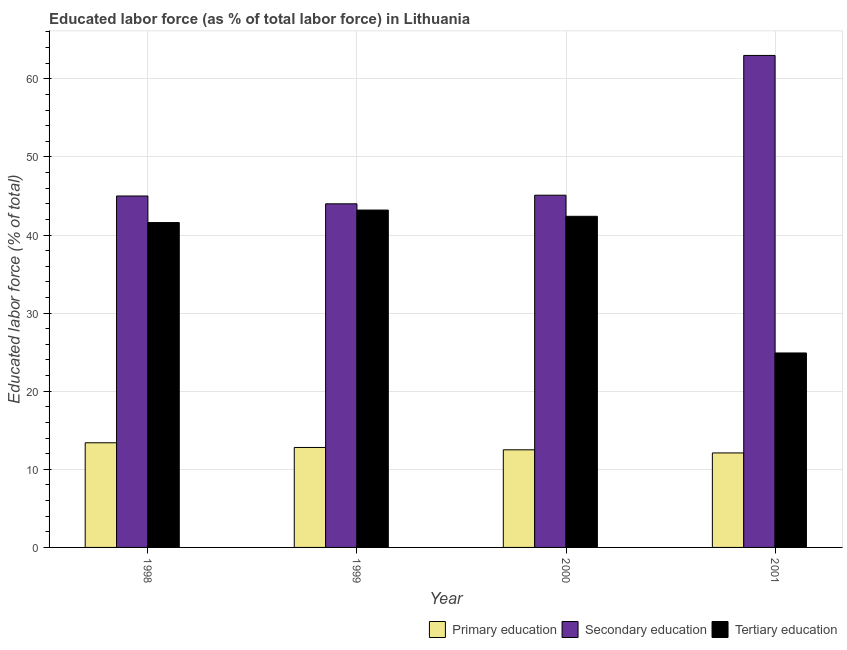How many groups of bars are there?
Provide a short and direct response. 4. Are the number of bars per tick equal to the number of legend labels?
Offer a very short reply. Yes. How many bars are there on the 4th tick from the left?
Give a very brief answer. 3. How many bars are there on the 4th tick from the right?
Offer a terse response. 3. What is the label of the 2nd group of bars from the left?
Ensure brevity in your answer.  1999. In how many cases, is the number of bars for a given year not equal to the number of legend labels?
Ensure brevity in your answer.  0. What is the percentage of labor force who received tertiary education in 2000?
Your response must be concise. 42.4. Across all years, what is the minimum percentage of labor force who received primary education?
Give a very brief answer. 12.1. In which year was the percentage of labor force who received secondary education maximum?
Provide a short and direct response. 2001. In which year was the percentage of labor force who received primary education minimum?
Provide a succinct answer. 2001. What is the total percentage of labor force who received tertiary education in the graph?
Offer a terse response. 152.1. What is the difference between the percentage of labor force who received tertiary education in 1998 and that in 2001?
Your answer should be very brief. 16.7. What is the difference between the percentage of labor force who received tertiary education in 2000 and the percentage of labor force who received primary education in 1998?
Your answer should be compact. 0.8. What is the average percentage of labor force who received tertiary education per year?
Give a very brief answer. 38.03. In how many years, is the percentage of labor force who received secondary education greater than 32 %?
Make the answer very short. 4. What is the ratio of the percentage of labor force who received primary education in 1999 to that in 2001?
Your response must be concise. 1.06. What is the difference between the highest and the second highest percentage of labor force who received tertiary education?
Ensure brevity in your answer.  0.8. What is the difference between the highest and the lowest percentage of labor force who received primary education?
Provide a succinct answer. 1.3. What does the 1st bar from the right in 1998 represents?
Provide a succinct answer. Tertiary education. Is it the case that in every year, the sum of the percentage of labor force who received primary education and percentage of labor force who received secondary education is greater than the percentage of labor force who received tertiary education?
Your response must be concise. Yes. How many bars are there?
Your response must be concise. 12. Are all the bars in the graph horizontal?
Your response must be concise. No. Are the values on the major ticks of Y-axis written in scientific E-notation?
Offer a terse response. No. Where does the legend appear in the graph?
Ensure brevity in your answer.  Bottom right. What is the title of the graph?
Provide a short and direct response. Educated labor force (as % of total labor force) in Lithuania. Does "Non-communicable diseases" appear as one of the legend labels in the graph?
Make the answer very short. No. What is the label or title of the X-axis?
Your answer should be very brief. Year. What is the label or title of the Y-axis?
Your response must be concise. Educated labor force (% of total). What is the Educated labor force (% of total) in Primary education in 1998?
Your answer should be very brief. 13.4. What is the Educated labor force (% of total) in Secondary education in 1998?
Make the answer very short. 45. What is the Educated labor force (% of total) of Tertiary education in 1998?
Make the answer very short. 41.6. What is the Educated labor force (% of total) in Primary education in 1999?
Your response must be concise. 12.8. What is the Educated labor force (% of total) in Tertiary education in 1999?
Your answer should be compact. 43.2. What is the Educated labor force (% of total) of Primary education in 2000?
Make the answer very short. 12.5. What is the Educated labor force (% of total) in Secondary education in 2000?
Offer a terse response. 45.1. What is the Educated labor force (% of total) of Tertiary education in 2000?
Keep it short and to the point. 42.4. What is the Educated labor force (% of total) in Primary education in 2001?
Provide a succinct answer. 12.1. What is the Educated labor force (% of total) of Secondary education in 2001?
Keep it short and to the point. 63. What is the Educated labor force (% of total) in Tertiary education in 2001?
Keep it short and to the point. 24.9. Across all years, what is the maximum Educated labor force (% of total) of Primary education?
Your answer should be very brief. 13.4. Across all years, what is the maximum Educated labor force (% of total) in Tertiary education?
Provide a succinct answer. 43.2. Across all years, what is the minimum Educated labor force (% of total) of Primary education?
Ensure brevity in your answer.  12.1. Across all years, what is the minimum Educated labor force (% of total) of Tertiary education?
Your response must be concise. 24.9. What is the total Educated labor force (% of total) in Primary education in the graph?
Ensure brevity in your answer.  50.8. What is the total Educated labor force (% of total) of Secondary education in the graph?
Provide a succinct answer. 197.1. What is the total Educated labor force (% of total) in Tertiary education in the graph?
Your response must be concise. 152.1. What is the difference between the Educated labor force (% of total) in Primary education in 1998 and that in 1999?
Give a very brief answer. 0.6. What is the difference between the Educated labor force (% of total) of Tertiary education in 1998 and that in 1999?
Your answer should be compact. -1.6. What is the difference between the Educated labor force (% of total) in Tertiary education in 1998 and that in 2001?
Keep it short and to the point. 16.7. What is the difference between the Educated labor force (% of total) in Primary education in 1999 and that in 2000?
Keep it short and to the point. 0.3. What is the difference between the Educated labor force (% of total) of Secondary education in 1999 and that in 2000?
Keep it short and to the point. -1.1. What is the difference between the Educated labor force (% of total) in Tertiary education in 1999 and that in 2001?
Your response must be concise. 18.3. What is the difference between the Educated labor force (% of total) of Primary education in 2000 and that in 2001?
Offer a terse response. 0.4. What is the difference between the Educated labor force (% of total) in Secondary education in 2000 and that in 2001?
Offer a terse response. -17.9. What is the difference between the Educated labor force (% of total) of Primary education in 1998 and the Educated labor force (% of total) of Secondary education in 1999?
Provide a succinct answer. -30.6. What is the difference between the Educated labor force (% of total) in Primary education in 1998 and the Educated labor force (% of total) in Tertiary education in 1999?
Provide a succinct answer. -29.8. What is the difference between the Educated labor force (% of total) in Primary education in 1998 and the Educated labor force (% of total) in Secondary education in 2000?
Provide a succinct answer. -31.7. What is the difference between the Educated labor force (% of total) in Secondary education in 1998 and the Educated labor force (% of total) in Tertiary education in 2000?
Your answer should be compact. 2.6. What is the difference between the Educated labor force (% of total) in Primary education in 1998 and the Educated labor force (% of total) in Secondary education in 2001?
Offer a very short reply. -49.6. What is the difference between the Educated labor force (% of total) in Primary education in 1998 and the Educated labor force (% of total) in Tertiary education in 2001?
Keep it short and to the point. -11.5. What is the difference between the Educated labor force (% of total) of Secondary education in 1998 and the Educated labor force (% of total) of Tertiary education in 2001?
Give a very brief answer. 20.1. What is the difference between the Educated labor force (% of total) of Primary education in 1999 and the Educated labor force (% of total) of Secondary education in 2000?
Make the answer very short. -32.3. What is the difference between the Educated labor force (% of total) in Primary education in 1999 and the Educated labor force (% of total) in Tertiary education in 2000?
Give a very brief answer. -29.6. What is the difference between the Educated labor force (% of total) of Secondary education in 1999 and the Educated labor force (% of total) of Tertiary education in 2000?
Give a very brief answer. 1.6. What is the difference between the Educated labor force (% of total) in Primary education in 1999 and the Educated labor force (% of total) in Secondary education in 2001?
Keep it short and to the point. -50.2. What is the difference between the Educated labor force (% of total) of Secondary education in 1999 and the Educated labor force (% of total) of Tertiary education in 2001?
Provide a short and direct response. 19.1. What is the difference between the Educated labor force (% of total) in Primary education in 2000 and the Educated labor force (% of total) in Secondary education in 2001?
Offer a very short reply. -50.5. What is the difference between the Educated labor force (% of total) of Primary education in 2000 and the Educated labor force (% of total) of Tertiary education in 2001?
Offer a terse response. -12.4. What is the difference between the Educated labor force (% of total) of Secondary education in 2000 and the Educated labor force (% of total) of Tertiary education in 2001?
Give a very brief answer. 20.2. What is the average Educated labor force (% of total) of Secondary education per year?
Your response must be concise. 49.27. What is the average Educated labor force (% of total) in Tertiary education per year?
Your answer should be very brief. 38.02. In the year 1998, what is the difference between the Educated labor force (% of total) of Primary education and Educated labor force (% of total) of Secondary education?
Your answer should be very brief. -31.6. In the year 1998, what is the difference between the Educated labor force (% of total) in Primary education and Educated labor force (% of total) in Tertiary education?
Your answer should be very brief. -28.2. In the year 1999, what is the difference between the Educated labor force (% of total) in Primary education and Educated labor force (% of total) in Secondary education?
Offer a very short reply. -31.2. In the year 1999, what is the difference between the Educated labor force (% of total) in Primary education and Educated labor force (% of total) in Tertiary education?
Offer a very short reply. -30.4. In the year 2000, what is the difference between the Educated labor force (% of total) of Primary education and Educated labor force (% of total) of Secondary education?
Make the answer very short. -32.6. In the year 2000, what is the difference between the Educated labor force (% of total) of Primary education and Educated labor force (% of total) of Tertiary education?
Offer a very short reply. -29.9. In the year 2000, what is the difference between the Educated labor force (% of total) of Secondary education and Educated labor force (% of total) of Tertiary education?
Offer a very short reply. 2.7. In the year 2001, what is the difference between the Educated labor force (% of total) in Primary education and Educated labor force (% of total) in Secondary education?
Your answer should be compact. -50.9. In the year 2001, what is the difference between the Educated labor force (% of total) of Secondary education and Educated labor force (% of total) of Tertiary education?
Provide a short and direct response. 38.1. What is the ratio of the Educated labor force (% of total) of Primary education in 1998 to that in 1999?
Provide a succinct answer. 1.05. What is the ratio of the Educated labor force (% of total) in Secondary education in 1998 to that in 1999?
Offer a very short reply. 1.02. What is the ratio of the Educated labor force (% of total) of Tertiary education in 1998 to that in 1999?
Offer a very short reply. 0.96. What is the ratio of the Educated labor force (% of total) of Primary education in 1998 to that in 2000?
Ensure brevity in your answer.  1.07. What is the ratio of the Educated labor force (% of total) of Tertiary education in 1998 to that in 2000?
Keep it short and to the point. 0.98. What is the ratio of the Educated labor force (% of total) of Primary education in 1998 to that in 2001?
Offer a terse response. 1.11. What is the ratio of the Educated labor force (% of total) of Secondary education in 1998 to that in 2001?
Ensure brevity in your answer.  0.71. What is the ratio of the Educated labor force (% of total) in Tertiary education in 1998 to that in 2001?
Your answer should be very brief. 1.67. What is the ratio of the Educated labor force (% of total) of Primary education in 1999 to that in 2000?
Give a very brief answer. 1.02. What is the ratio of the Educated labor force (% of total) in Secondary education in 1999 to that in 2000?
Make the answer very short. 0.98. What is the ratio of the Educated labor force (% of total) of Tertiary education in 1999 to that in 2000?
Your response must be concise. 1.02. What is the ratio of the Educated labor force (% of total) in Primary education in 1999 to that in 2001?
Ensure brevity in your answer.  1.06. What is the ratio of the Educated labor force (% of total) in Secondary education in 1999 to that in 2001?
Ensure brevity in your answer.  0.7. What is the ratio of the Educated labor force (% of total) in Tertiary education in 1999 to that in 2001?
Ensure brevity in your answer.  1.73. What is the ratio of the Educated labor force (% of total) of Primary education in 2000 to that in 2001?
Provide a succinct answer. 1.03. What is the ratio of the Educated labor force (% of total) in Secondary education in 2000 to that in 2001?
Offer a very short reply. 0.72. What is the ratio of the Educated labor force (% of total) in Tertiary education in 2000 to that in 2001?
Offer a very short reply. 1.7. What is the difference between the highest and the second highest Educated labor force (% of total) of Tertiary education?
Offer a very short reply. 0.8. What is the difference between the highest and the lowest Educated labor force (% of total) in Primary education?
Your answer should be compact. 1.3. What is the difference between the highest and the lowest Educated labor force (% of total) of Tertiary education?
Give a very brief answer. 18.3. 